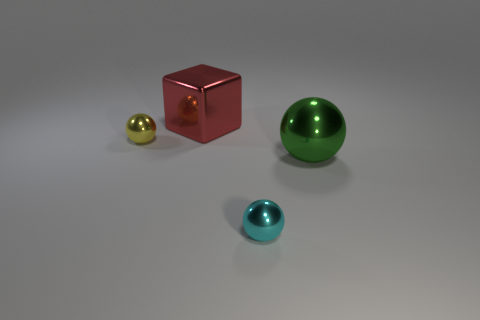Add 4 small cyan metal spheres. How many objects exist? 8 Subtract all blocks. How many objects are left? 3 Add 1 big cyan objects. How many big cyan objects exist? 1 Subtract 0 brown cylinders. How many objects are left? 4 Subtract all large metallic balls. Subtract all cyan balls. How many objects are left? 2 Add 1 balls. How many balls are left? 4 